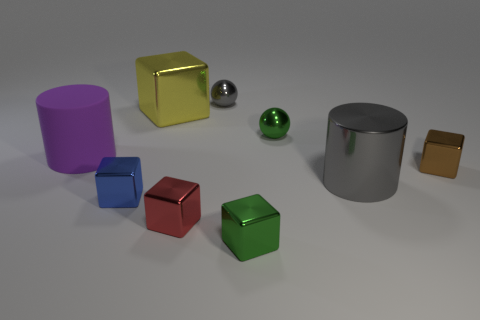Subtract all large yellow cubes. How many cubes are left? 4 Subtract all blue cubes. How many cubes are left? 4 Add 1 large gray cylinders. How many objects exist? 10 Subtract 1 cylinders. How many cylinders are left? 1 Subtract all cylinders. How many objects are left? 7 Subtract all red cylinders. How many yellow blocks are left? 1 Subtract all tiny gray things. Subtract all yellow blocks. How many objects are left? 7 Add 7 small gray objects. How many small gray objects are left? 8 Add 6 gray spheres. How many gray spheres exist? 7 Subtract 0 blue cylinders. How many objects are left? 9 